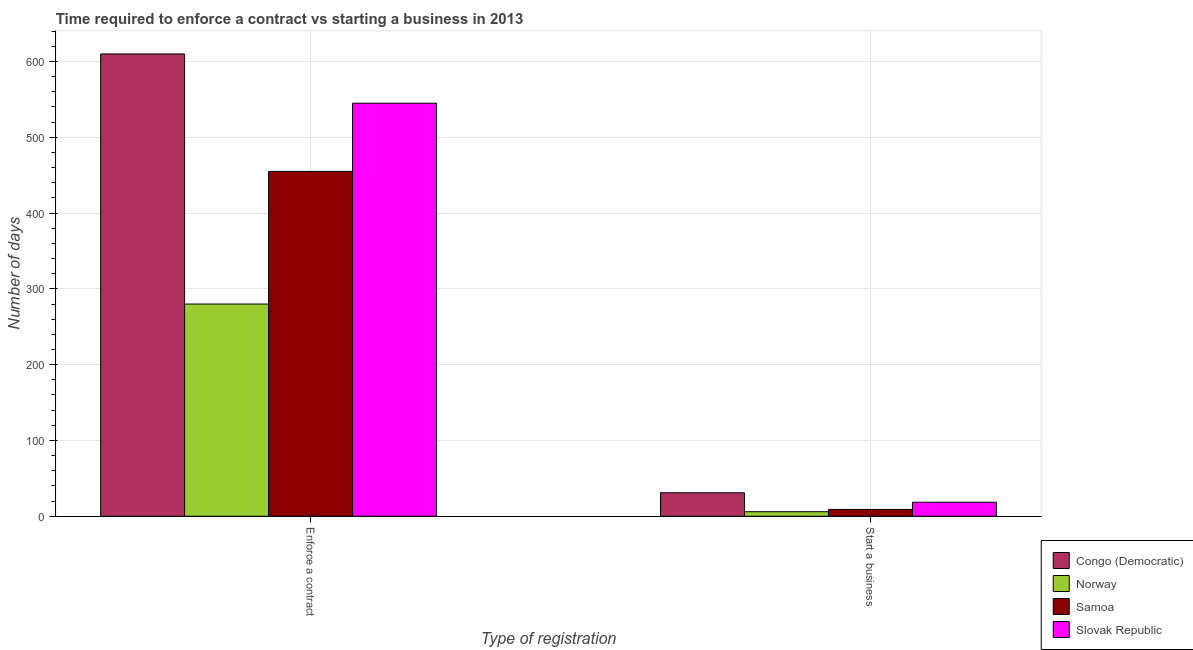How many groups of bars are there?
Give a very brief answer. 2. Are the number of bars on each tick of the X-axis equal?
Make the answer very short. Yes. How many bars are there on the 1st tick from the left?
Offer a terse response. 4. What is the label of the 1st group of bars from the left?
Provide a succinct answer. Enforce a contract. What is the number of days to enforece a contract in Congo (Democratic)?
Provide a short and direct response. 610. Across all countries, what is the maximum number of days to enforece a contract?
Ensure brevity in your answer.  610. Across all countries, what is the minimum number of days to start a business?
Your answer should be compact. 6. In which country was the number of days to enforece a contract maximum?
Your response must be concise. Congo (Democratic). What is the total number of days to enforece a contract in the graph?
Your answer should be very brief. 1890. What is the difference between the number of days to enforece a contract in Congo (Democratic) and that in Samoa?
Give a very brief answer. 155. What is the difference between the number of days to enforece a contract in Samoa and the number of days to start a business in Norway?
Ensure brevity in your answer.  449. What is the average number of days to start a business per country?
Offer a terse response. 16.12. What is the difference between the number of days to start a business and number of days to enforece a contract in Samoa?
Keep it short and to the point. -446. What is the ratio of the number of days to start a business in Slovak Republic to that in Samoa?
Provide a succinct answer. 2.06. Is the number of days to enforece a contract in Slovak Republic less than that in Congo (Democratic)?
Offer a very short reply. Yes. In how many countries, is the number of days to enforece a contract greater than the average number of days to enforece a contract taken over all countries?
Offer a terse response. 2. What does the 4th bar from the left in Enforce a contract represents?
Give a very brief answer. Slovak Republic. What does the 2nd bar from the right in Enforce a contract represents?
Give a very brief answer. Samoa. How many countries are there in the graph?
Provide a succinct answer. 4. What is the difference between two consecutive major ticks on the Y-axis?
Offer a terse response. 100. Does the graph contain any zero values?
Your answer should be very brief. No. Does the graph contain grids?
Provide a short and direct response. Yes. Where does the legend appear in the graph?
Provide a short and direct response. Bottom right. How are the legend labels stacked?
Your response must be concise. Vertical. What is the title of the graph?
Your answer should be compact. Time required to enforce a contract vs starting a business in 2013. Does "Nepal" appear as one of the legend labels in the graph?
Your response must be concise. No. What is the label or title of the X-axis?
Your answer should be very brief. Type of registration. What is the label or title of the Y-axis?
Provide a succinct answer. Number of days. What is the Number of days of Congo (Democratic) in Enforce a contract?
Provide a short and direct response. 610. What is the Number of days in Norway in Enforce a contract?
Provide a succinct answer. 280. What is the Number of days in Samoa in Enforce a contract?
Provide a succinct answer. 455. What is the Number of days in Slovak Republic in Enforce a contract?
Offer a very short reply. 545. What is the Number of days of Congo (Democratic) in Start a business?
Offer a very short reply. 31. What is the Number of days in Norway in Start a business?
Provide a short and direct response. 6. What is the Number of days in Slovak Republic in Start a business?
Keep it short and to the point. 18.5. Across all Type of registration, what is the maximum Number of days in Congo (Democratic)?
Give a very brief answer. 610. Across all Type of registration, what is the maximum Number of days in Norway?
Give a very brief answer. 280. Across all Type of registration, what is the maximum Number of days of Samoa?
Your answer should be compact. 455. Across all Type of registration, what is the maximum Number of days in Slovak Republic?
Offer a terse response. 545. What is the total Number of days of Congo (Democratic) in the graph?
Give a very brief answer. 641. What is the total Number of days in Norway in the graph?
Your response must be concise. 286. What is the total Number of days in Samoa in the graph?
Make the answer very short. 464. What is the total Number of days in Slovak Republic in the graph?
Provide a succinct answer. 563.5. What is the difference between the Number of days in Congo (Democratic) in Enforce a contract and that in Start a business?
Provide a succinct answer. 579. What is the difference between the Number of days in Norway in Enforce a contract and that in Start a business?
Keep it short and to the point. 274. What is the difference between the Number of days in Samoa in Enforce a contract and that in Start a business?
Provide a short and direct response. 446. What is the difference between the Number of days of Slovak Republic in Enforce a contract and that in Start a business?
Offer a very short reply. 526.5. What is the difference between the Number of days of Congo (Democratic) in Enforce a contract and the Number of days of Norway in Start a business?
Offer a very short reply. 604. What is the difference between the Number of days of Congo (Democratic) in Enforce a contract and the Number of days of Samoa in Start a business?
Make the answer very short. 601. What is the difference between the Number of days in Congo (Democratic) in Enforce a contract and the Number of days in Slovak Republic in Start a business?
Make the answer very short. 591.5. What is the difference between the Number of days of Norway in Enforce a contract and the Number of days of Samoa in Start a business?
Make the answer very short. 271. What is the difference between the Number of days in Norway in Enforce a contract and the Number of days in Slovak Republic in Start a business?
Provide a succinct answer. 261.5. What is the difference between the Number of days of Samoa in Enforce a contract and the Number of days of Slovak Republic in Start a business?
Your answer should be very brief. 436.5. What is the average Number of days of Congo (Democratic) per Type of registration?
Offer a very short reply. 320.5. What is the average Number of days of Norway per Type of registration?
Offer a very short reply. 143. What is the average Number of days in Samoa per Type of registration?
Your answer should be very brief. 232. What is the average Number of days of Slovak Republic per Type of registration?
Give a very brief answer. 281.75. What is the difference between the Number of days in Congo (Democratic) and Number of days in Norway in Enforce a contract?
Ensure brevity in your answer.  330. What is the difference between the Number of days in Congo (Democratic) and Number of days in Samoa in Enforce a contract?
Offer a very short reply. 155. What is the difference between the Number of days of Congo (Democratic) and Number of days of Slovak Republic in Enforce a contract?
Make the answer very short. 65. What is the difference between the Number of days in Norway and Number of days in Samoa in Enforce a contract?
Your response must be concise. -175. What is the difference between the Number of days of Norway and Number of days of Slovak Republic in Enforce a contract?
Offer a terse response. -265. What is the difference between the Number of days of Samoa and Number of days of Slovak Republic in Enforce a contract?
Give a very brief answer. -90. What is the difference between the Number of days in Congo (Democratic) and Number of days in Samoa in Start a business?
Make the answer very short. 22. What is the difference between the Number of days of Congo (Democratic) and Number of days of Slovak Republic in Start a business?
Keep it short and to the point. 12.5. What is the difference between the Number of days in Norway and Number of days in Slovak Republic in Start a business?
Provide a short and direct response. -12.5. What is the difference between the Number of days of Samoa and Number of days of Slovak Republic in Start a business?
Make the answer very short. -9.5. What is the ratio of the Number of days of Congo (Democratic) in Enforce a contract to that in Start a business?
Provide a succinct answer. 19.68. What is the ratio of the Number of days in Norway in Enforce a contract to that in Start a business?
Your response must be concise. 46.67. What is the ratio of the Number of days of Samoa in Enforce a contract to that in Start a business?
Ensure brevity in your answer.  50.56. What is the ratio of the Number of days in Slovak Republic in Enforce a contract to that in Start a business?
Ensure brevity in your answer.  29.46. What is the difference between the highest and the second highest Number of days in Congo (Democratic)?
Keep it short and to the point. 579. What is the difference between the highest and the second highest Number of days of Norway?
Give a very brief answer. 274. What is the difference between the highest and the second highest Number of days of Samoa?
Provide a short and direct response. 446. What is the difference between the highest and the second highest Number of days of Slovak Republic?
Offer a very short reply. 526.5. What is the difference between the highest and the lowest Number of days in Congo (Democratic)?
Provide a short and direct response. 579. What is the difference between the highest and the lowest Number of days in Norway?
Offer a terse response. 274. What is the difference between the highest and the lowest Number of days in Samoa?
Your answer should be compact. 446. What is the difference between the highest and the lowest Number of days in Slovak Republic?
Provide a short and direct response. 526.5. 